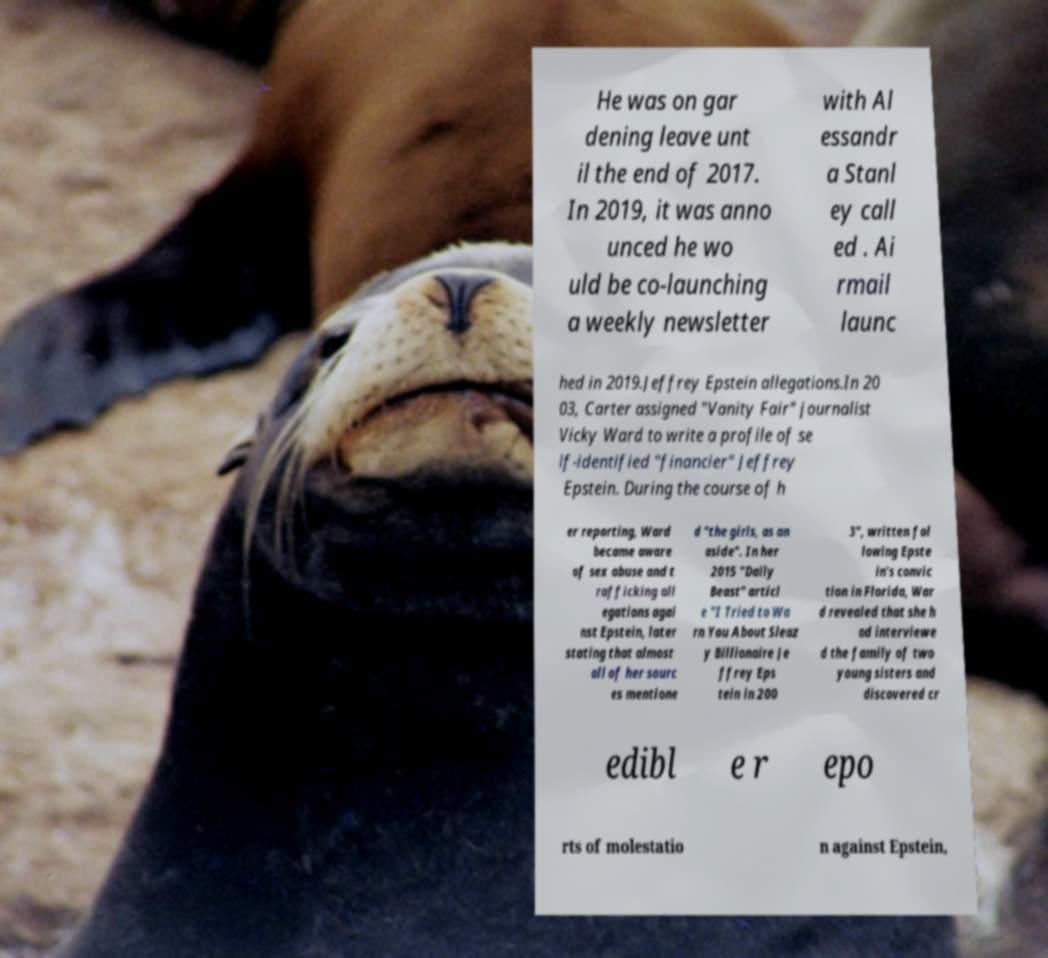Can you accurately transcribe the text from the provided image for me? He was on gar dening leave unt il the end of 2017. In 2019, it was anno unced he wo uld be co-launching a weekly newsletter with Al essandr a Stanl ey call ed . Ai rmail launc hed in 2019.Jeffrey Epstein allegations.In 20 03, Carter assigned "Vanity Fair" journalist Vicky Ward to write a profile of se lf-identified "financier" Jeffrey Epstein. During the course of h er reporting, Ward became aware of sex abuse and t rafficking all egations agai nst Epstein, later stating that almost all of her sourc es mentione d "the girls, as an aside". In her 2015 "Daily Beast" articl e "I Tried to Wa rn You About Sleaz y Billionaire Je ffrey Eps tein in 200 3", written fol lowing Epste in's convic tion in Florida, War d revealed that she h ad interviewe d the family of two young sisters and discovered cr edibl e r epo rts of molestatio n against Epstein, 